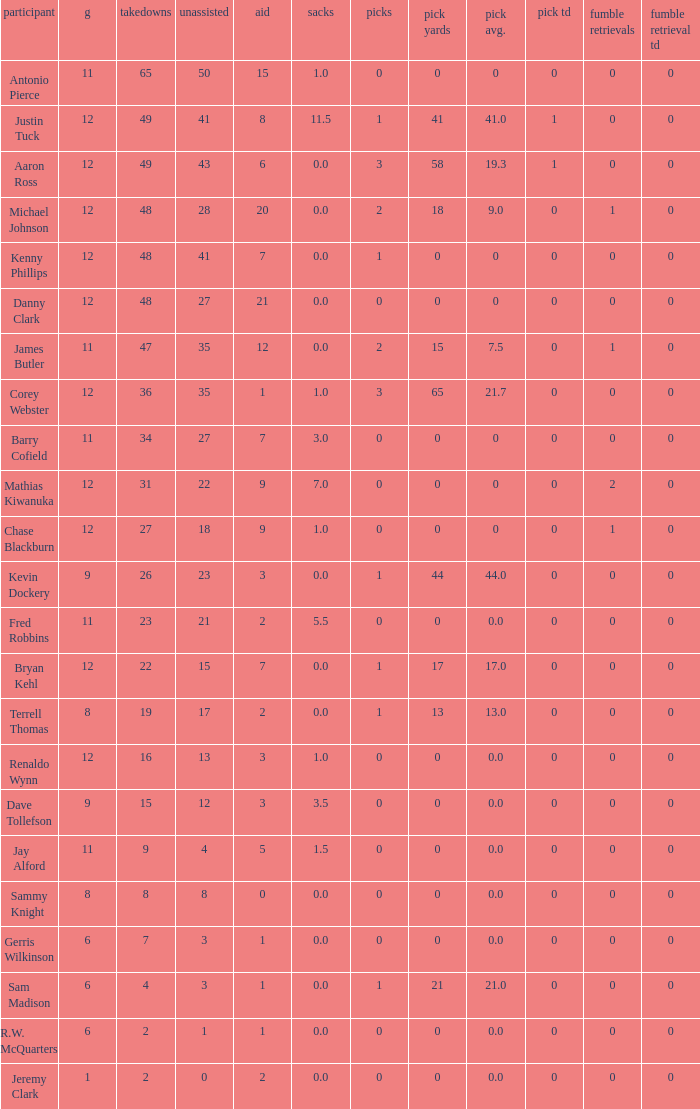Name the least int yards when sacks is 11.5 41.0. I'm looking to parse the entire table for insights. Could you assist me with that? {'header': ['participant', 'g', 'takedowns', 'unassisted', 'aid', 'sacks', 'picks', 'pick yards', 'pick avg.', 'pick td', 'fumble retrievals', 'fumble retrieval td'], 'rows': [['Antonio Pierce', '11', '65', '50', '15', '1.0', '0', '0', '0', '0', '0', '0'], ['Justin Tuck', '12', '49', '41', '8', '11.5', '1', '41', '41.0', '1', '0', '0'], ['Aaron Ross', '12', '49', '43', '6', '0.0', '3', '58', '19.3', '1', '0', '0'], ['Michael Johnson', '12', '48', '28', '20', '0.0', '2', '18', '9.0', '0', '1', '0'], ['Kenny Phillips', '12', '48', '41', '7', '0.0', '1', '0', '0', '0', '0', '0'], ['Danny Clark', '12', '48', '27', '21', '0.0', '0', '0', '0', '0', '0', '0'], ['James Butler', '11', '47', '35', '12', '0.0', '2', '15', '7.5', '0', '1', '0'], ['Corey Webster', '12', '36', '35', '1', '1.0', '3', '65', '21.7', '0', '0', '0'], ['Barry Cofield', '11', '34', '27', '7', '3.0', '0', '0', '0', '0', '0', '0'], ['Mathias Kiwanuka', '12', '31', '22', '9', '7.0', '0', '0', '0', '0', '2', '0'], ['Chase Blackburn', '12', '27', '18', '9', '1.0', '0', '0', '0', '0', '1', '0'], ['Kevin Dockery', '9', '26', '23', '3', '0.0', '1', '44', '44.0', '0', '0', '0'], ['Fred Robbins', '11', '23', '21', '2', '5.5', '0', '0', '0.0', '0', '0', '0'], ['Bryan Kehl', '12', '22', '15', '7', '0.0', '1', '17', '17.0', '0', '0', '0'], ['Terrell Thomas', '8', '19', '17', '2', '0.0', '1', '13', '13.0', '0', '0', '0'], ['Renaldo Wynn', '12', '16', '13', '3', '1.0', '0', '0', '0.0', '0', '0', '0'], ['Dave Tollefson', '9', '15', '12', '3', '3.5', '0', '0', '0.0', '0', '0', '0'], ['Jay Alford', '11', '9', '4', '5', '1.5', '0', '0', '0.0', '0', '0', '0'], ['Sammy Knight', '8', '8', '8', '0', '0.0', '0', '0', '0.0', '0', '0', '0'], ['Gerris Wilkinson', '6', '7', '3', '1', '0.0', '0', '0', '0.0', '0', '0', '0'], ['Sam Madison', '6', '4', '3', '1', '0.0', '1', '21', '21.0', '0', '0', '0'], ['R.W. McQuarters', '6', '2', '1', '1', '0.0', '0', '0', '0.0', '0', '0', '0'], ['Jeremy Clark', '1', '2', '0', '2', '0.0', '0', '0', '0.0', '0', '0', '0']]} 